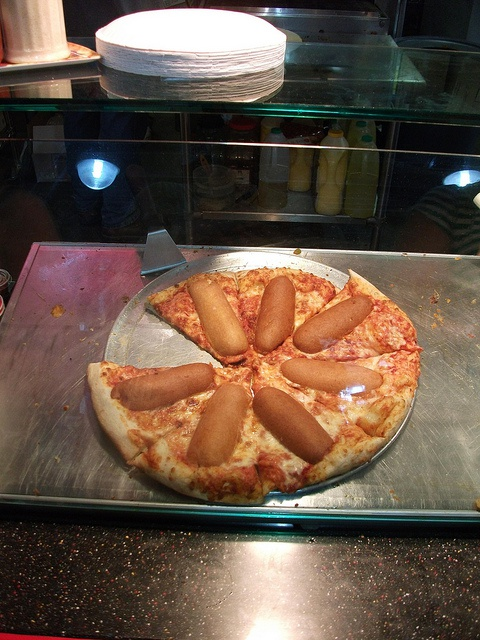Describe the objects in this image and their specific colors. I can see dining table in maroon, black, gray, and ivory tones, pizza in maroon, tan, brown, salmon, and red tones, hot dog in maroon, brown, tan, and salmon tones, pizza in maroon, brown, and tan tones, and knife in maroon, black, and gray tones in this image. 